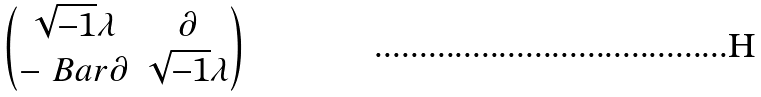Convert formula to latex. <formula><loc_0><loc_0><loc_500><loc_500>\begin{pmatrix} \sqrt { - 1 } \lambda & \partial \\ - \ B a r { \partial } & \sqrt { - 1 } \lambda \end{pmatrix}</formula> 